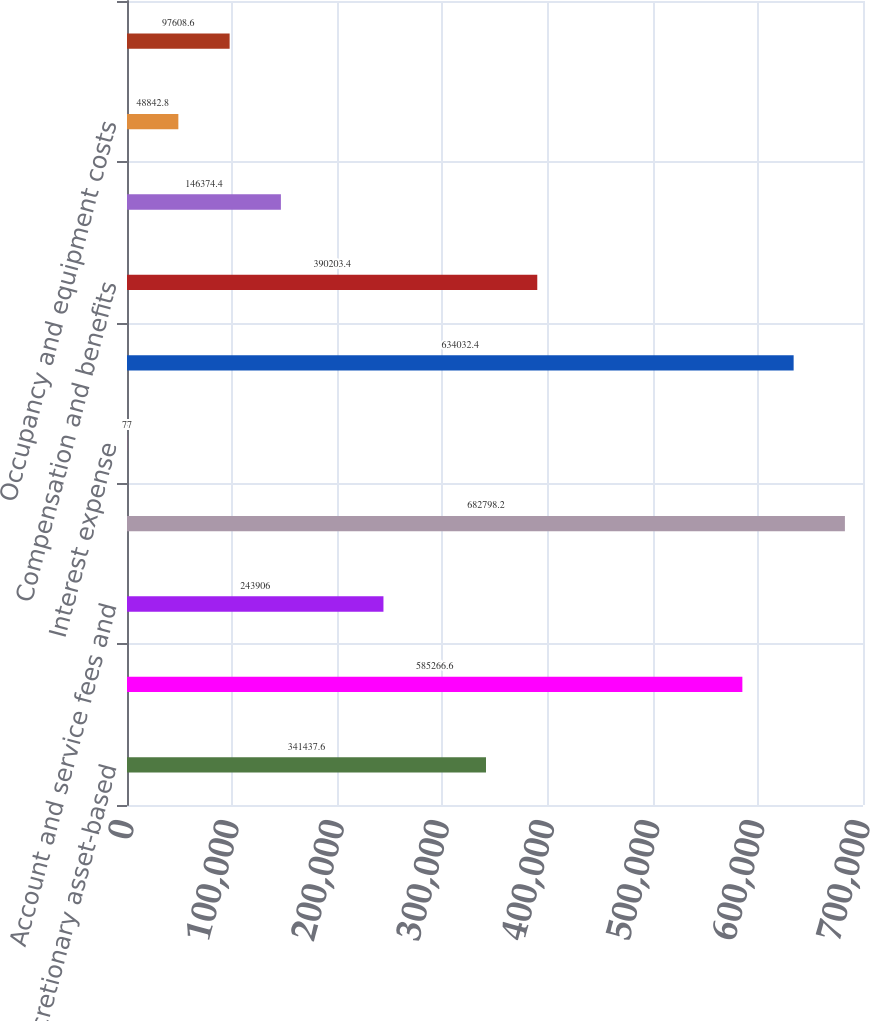Convert chart to OTSL. <chart><loc_0><loc_0><loc_500><loc_500><bar_chart><fcel>Non-discretionary asset-based<fcel>Sub-total investment advisory<fcel>Account and service fees and<fcel>Total revenues<fcel>Interest expense<fcel>Net revenues<fcel>Compensation and benefits<fcel>Communications and information<fcel>Occupancy and equipment costs<fcel>Business development<nl><fcel>341438<fcel>585267<fcel>243906<fcel>682798<fcel>77<fcel>634032<fcel>390203<fcel>146374<fcel>48842.8<fcel>97608.6<nl></chart> 